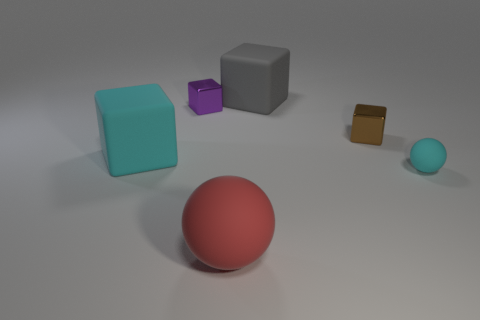Subtract all tiny brown shiny cubes. How many cubes are left? 3 Subtract 1 cubes. How many cubes are left? 3 Subtract all brown cubes. How many cubes are left? 3 Add 1 tiny shiny objects. How many objects exist? 7 Subtract all red blocks. Subtract all cyan cylinders. How many blocks are left? 4 Subtract all cubes. How many objects are left? 2 Add 2 large red balls. How many large red balls exist? 3 Subtract 0 blue cylinders. How many objects are left? 6 Subtract all blue matte balls. Subtract all big matte spheres. How many objects are left? 5 Add 3 cubes. How many cubes are left? 7 